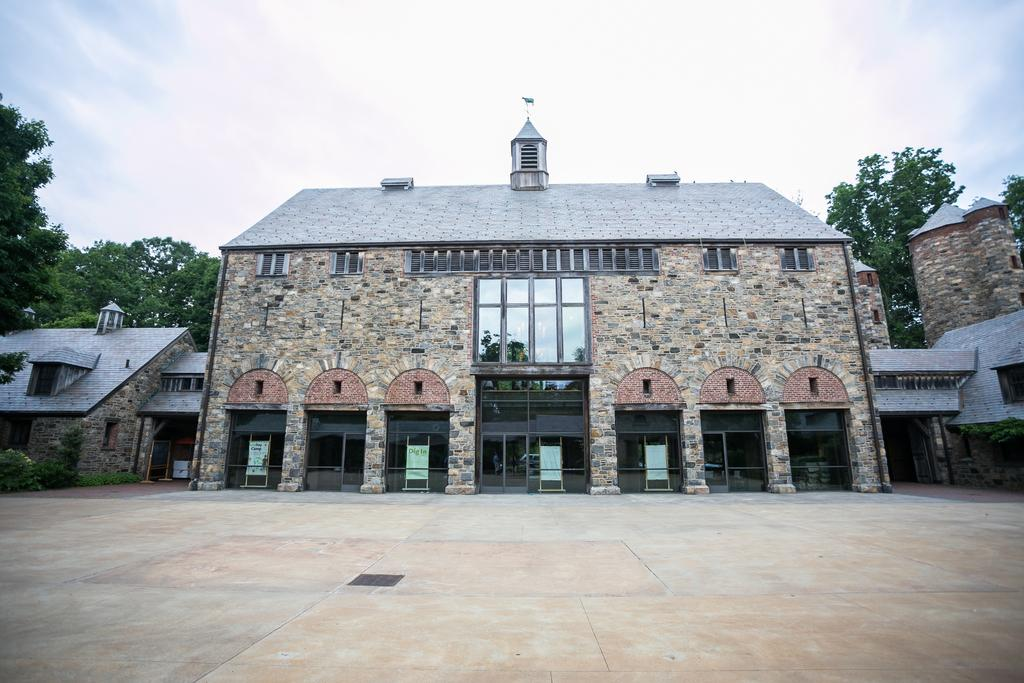What type of surface is visible at the bottom of the image? There is a floor visible in the image. What type of structures can be seen in the image? There are buildings in the image, and their roofs are also visible. What architectural features can be seen on the buildings? Windows are visible in the image, as well as glass doors. What type of advertisements are present in the image? Hoardings on stands are present in the image. What type of vegetation is visible in the image? Trees are visible in the image. What is visible in the sky in the image? Clouds are visible in the sky. How many sisters are playing on the island in the image? There is no island or sisters present in the image. What type of material is the lead used for in the image? There is no lead or any reference to lead in the image. 